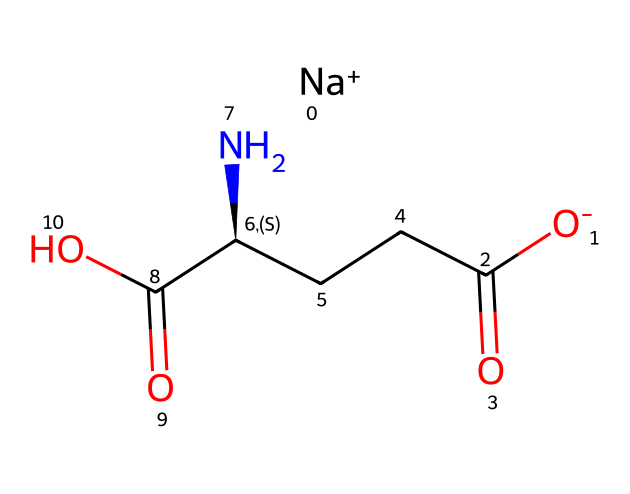How many carbon atoms are in monosodium glutamate? In the provided SMILES representation, we can count the carbon atoms represented by "C". There are five carbon atoms present in the structure.
Answer: five What is the charge on the sodium ion in MSG? The notation "[Na+]" in the SMILES indicates that the sodium ion carries a positive charge, which is denoted by the "+" sign.
Answer: positive How many nitrogen atoms are found in monosodium glutamate? By examining the SMILES representation, we can identify "N" which appears once, indicating that there is one nitrogen atom in MSG.
Answer: one What type of functional group is present in MSG that contributes to its flavor enhancement properties? MSG contains a carboxylic acid functional group (–COOH) as indicated by the "C(=O)O" portion of the SMILES. This group is known to enhance umami flavor.
Answer: carboxylic acid Which part of MSG makes it soluble in water? The presence of the ionic character in the sodium ion "[Na+]" and the negatively charged functional groups aids its solubility in water, allowing the MSG to dissolve efficiently.
Answer: ionic character What type of compound is monosodium glutamate classified as? MSG is classified as an amino acid derivative due to the presence of both an amino group (–NH2) and a carboxylic acid group (–COOH) in its structure, making it a type of food additive.
Answer: amino acid derivative 